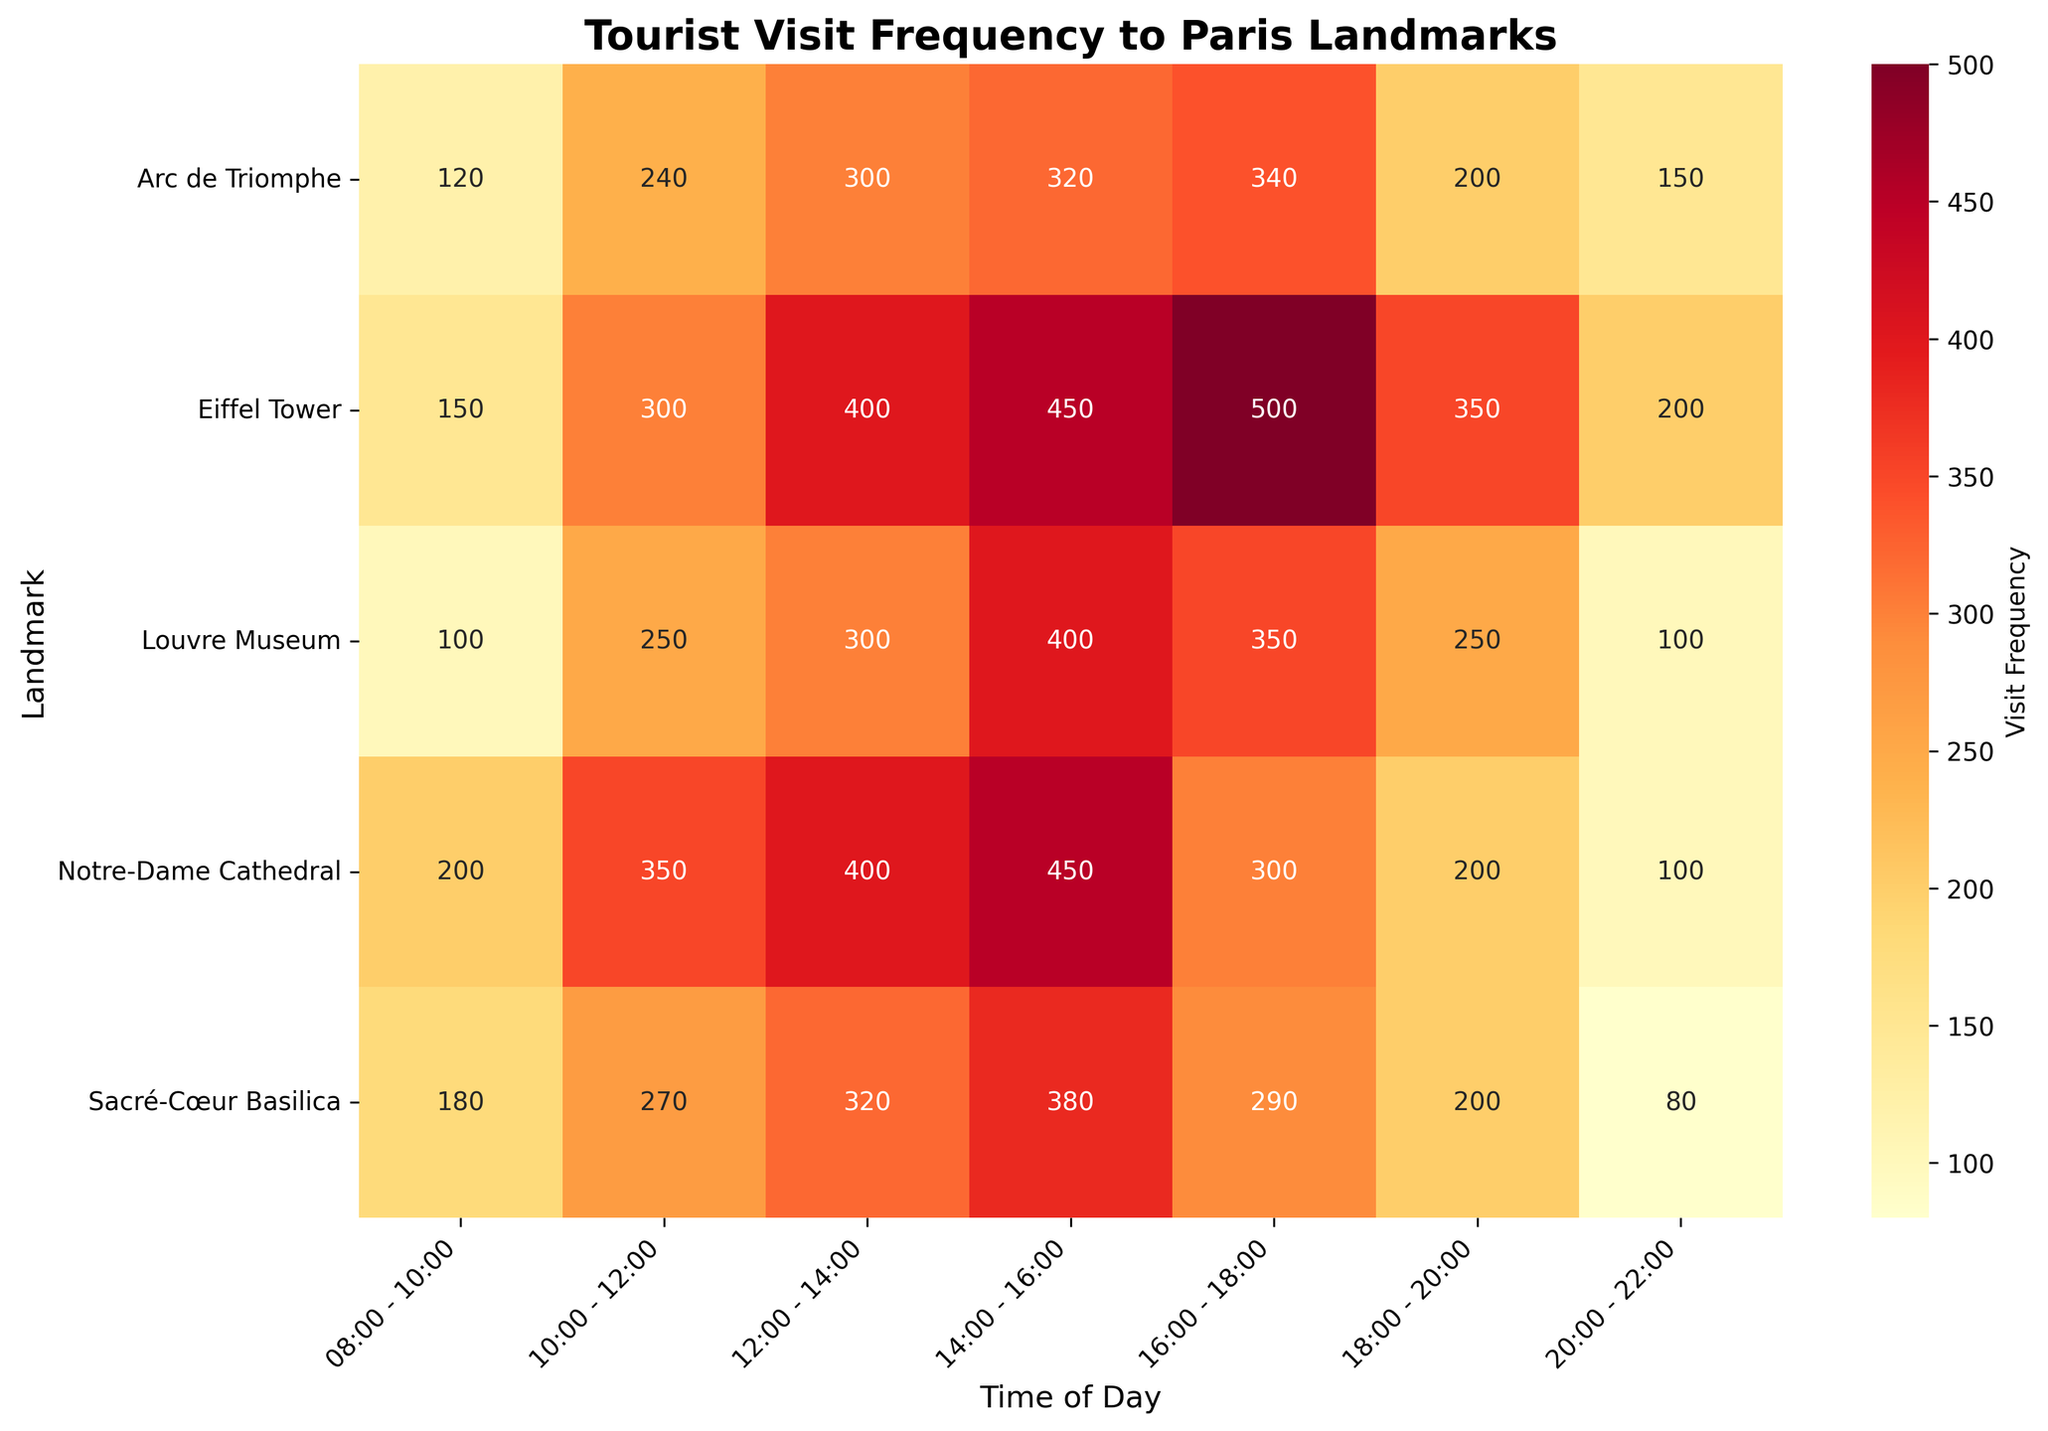What is the title of the heatmap? The title of the heatmap is usually displayed at the top of the figure. By looking at the top region, one can find the title.
Answer: Tourist Visit Frequency to Paris Landmarks Which landmark has the highest visit frequency between 16:00 - 18:00? To determine this, locate the 16:00 - 18:00 column in the heatmap and identify the landmark with the highest frequency value in that column.
Answer: Eiffel Tower During which time of day does the Louvre Museum receive the least number of visitors? To answer this, check the row corresponding to "Louvre Museum" and find the column with the smallest value.
Answer: 08:00 - 10:00 and 20:00 - 22:00 What is the range of visit frequencies for the Eiffel Tower? To find the range, identify the minimum and maximum visit frequencies for the Eiffel Tower from all time slots and calculate the difference between these values.
Answer: 150 to 500 Which time slots have the highest and lowest average visit frequencies across all landmarks? Calculate the average visit frequency for each time slot by summing all frequencies in each column and dividing by the number of landmarks. Identify the columns with the highest and lowest averages.
Answer: 16:00 - 18:00 and 20:00 - 22:00 During which time slot does the Notre-Dame Cathedral have the same number of visitors as the highest visitor frequency for the Arc de Triomphe? First, identify the highest visitor frequency for the Arc de Triomphe. Then, locate the time slot in Notre-Dame Cathedral's row that matches this frequency.
Answer: 12:00 - 14:00 Compare the visit frequencies of the Sacré-Cœur Basilica and Arc de Triomphe at 18:00 - 20:00. Which one has more visitors and by how much? Check the visit frequencies for both landmarks at the specified time. Subtract the smaller value from the larger one to get the difference.
Answer: Sacré-Cœur Basilica by 80 Which landmark has the most varied visit frequencies throughout the day? Calculate the range (difference between maximum and minimum values) of visit frequencies for each landmark. The landmark with the largest range has the most varied visit frequencies.
Answer: Eiffel Tower 